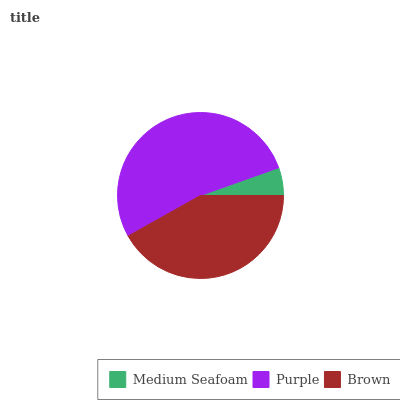Is Medium Seafoam the minimum?
Answer yes or no. Yes. Is Purple the maximum?
Answer yes or no. Yes. Is Brown the minimum?
Answer yes or no. No. Is Brown the maximum?
Answer yes or no. No. Is Purple greater than Brown?
Answer yes or no. Yes. Is Brown less than Purple?
Answer yes or no. Yes. Is Brown greater than Purple?
Answer yes or no. No. Is Purple less than Brown?
Answer yes or no. No. Is Brown the high median?
Answer yes or no. Yes. Is Brown the low median?
Answer yes or no. Yes. Is Medium Seafoam the high median?
Answer yes or no. No. Is Medium Seafoam the low median?
Answer yes or no. No. 